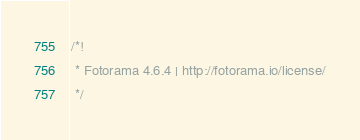<code> <loc_0><loc_0><loc_500><loc_500><_CSS_>/*!
 * Fotorama 4.6.4 | http://fotorama.io/license/
 */</code> 